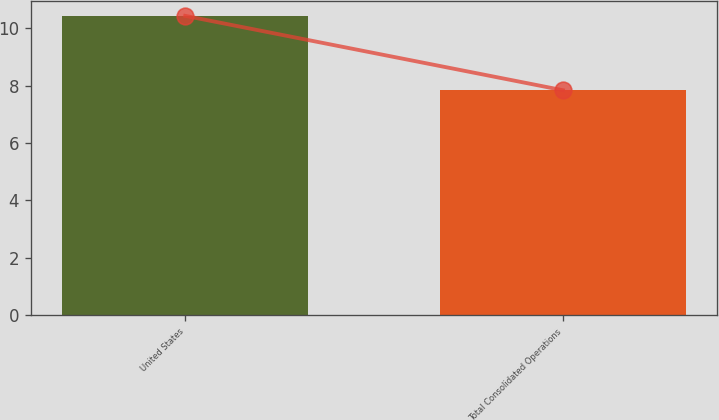Convert chart to OTSL. <chart><loc_0><loc_0><loc_500><loc_500><bar_chart><fcel>United States<fcel>Total Consolidated Operations<nl><fcel>10.43<fcel>7.84<nl></chart> 